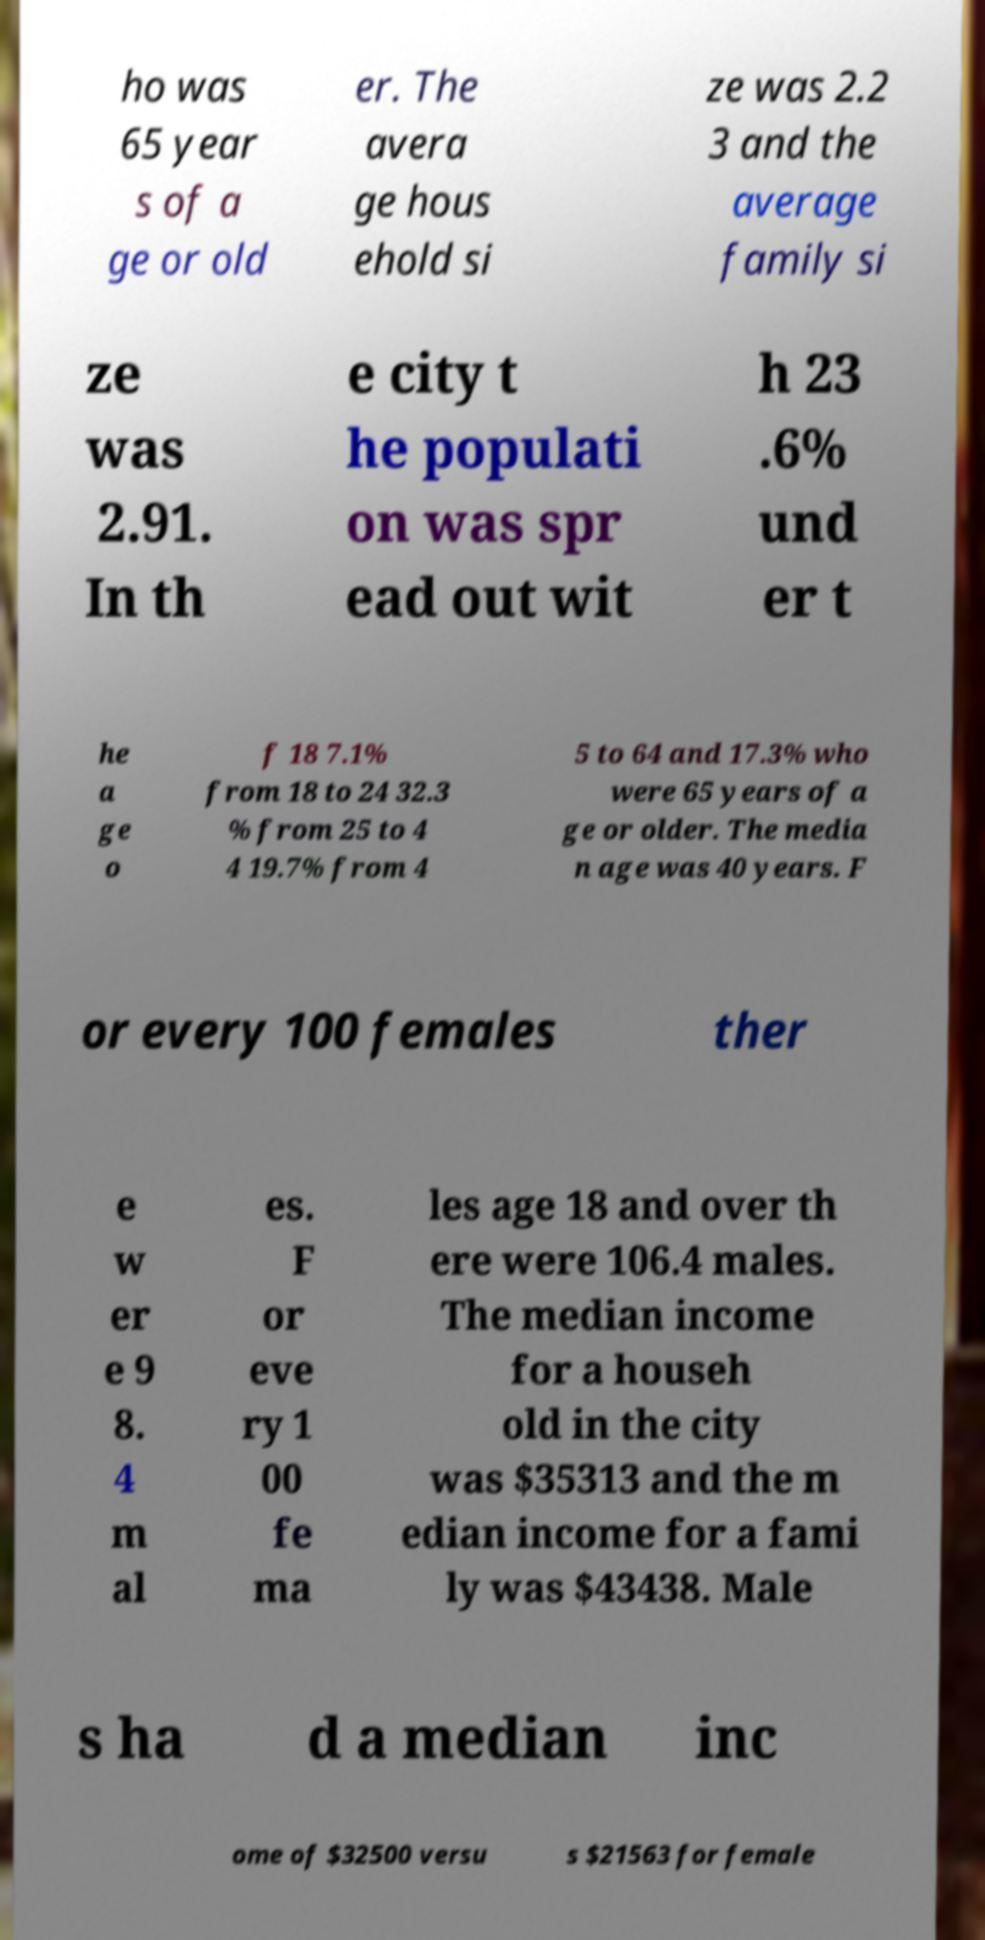Could you extract and type out the text from this image? ho was 65 year s of a ge or old er. The avera ge hous ehold si ze was 2.2 3 and the average family si ze was 2.91. In th e city t he populati on was spr ead out wit h 23 .6% und er t he a ge o f 18 7.1% from 18 to 24 32.3 % from 25 to 4 4 19.7% from 4 5 to 64 and 17.3% who were 65 years of a ge or older. The media n age was 40 years. F or every 100 females ther e w er e 9 8. 4 m al es. F or eve ry 1 00 fe ma les age 18 and over th ere were 106.4 males. The median income for a househ old in the city was $35313 and the m edian income for a fami ly was $43438. Male s ha d a median inc ome of $32500 versu s $21563 for female 